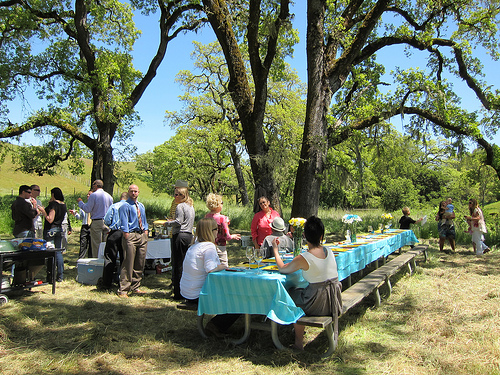<image>
Can you confirm if the tree is behind the table? Yes. From this viewpoint, the tree is positioned behind the table, with the table partially or fully occluding the tree. Is there a flowers to the right of the person? Yes. From this viewpoint, the flowers is positioned to the right side relative to the person. 